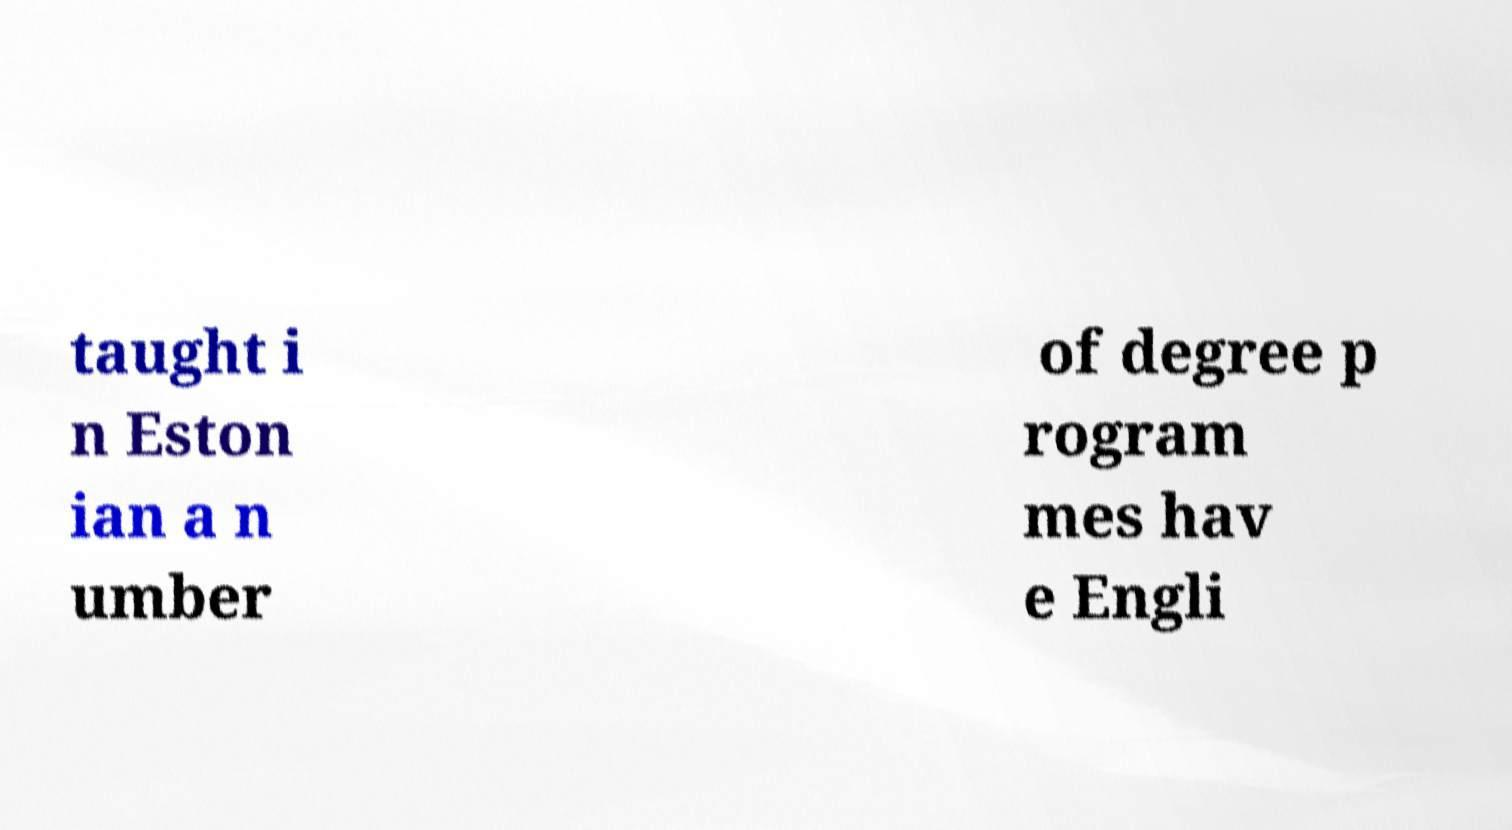I need the written content from this picture converted into text. Can you do that? taught i n Eston ian a n umber of degree p rogram mes hav e Engli 